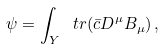<formula> <loc_0><loc_0><loc_500><loc_500>\psi = \int _ { Y } \ t r ( { \bar { c } } D ^ { \mu } B _ { \mu } ) \, ,</formula> 